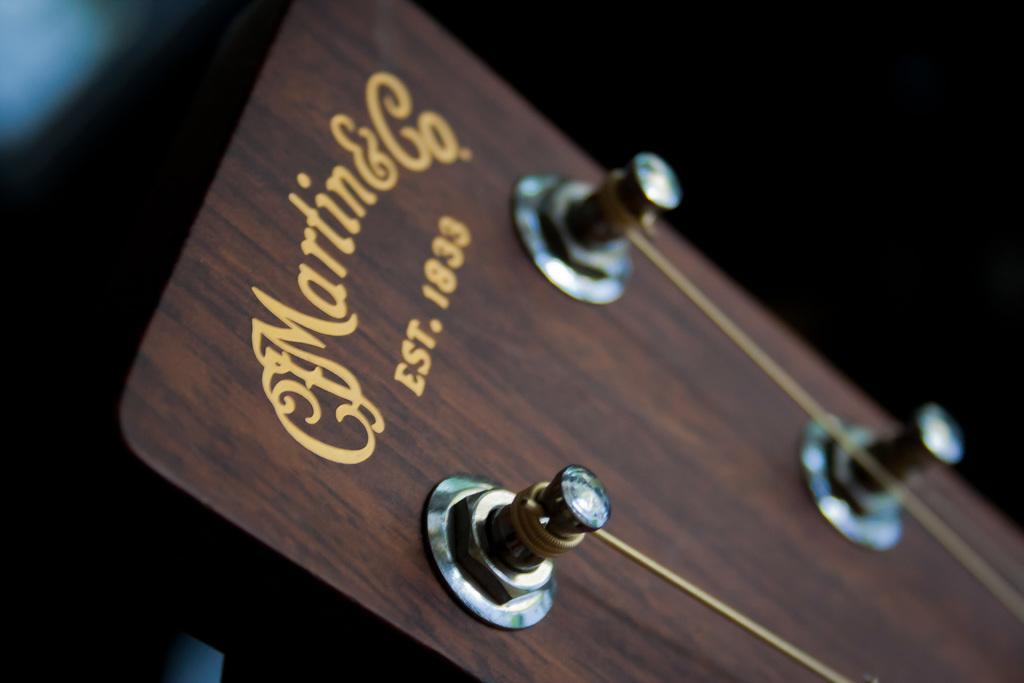Describe this image in one or two sentences. In this image I can see a part of Guitar and also I can see strings on it. 